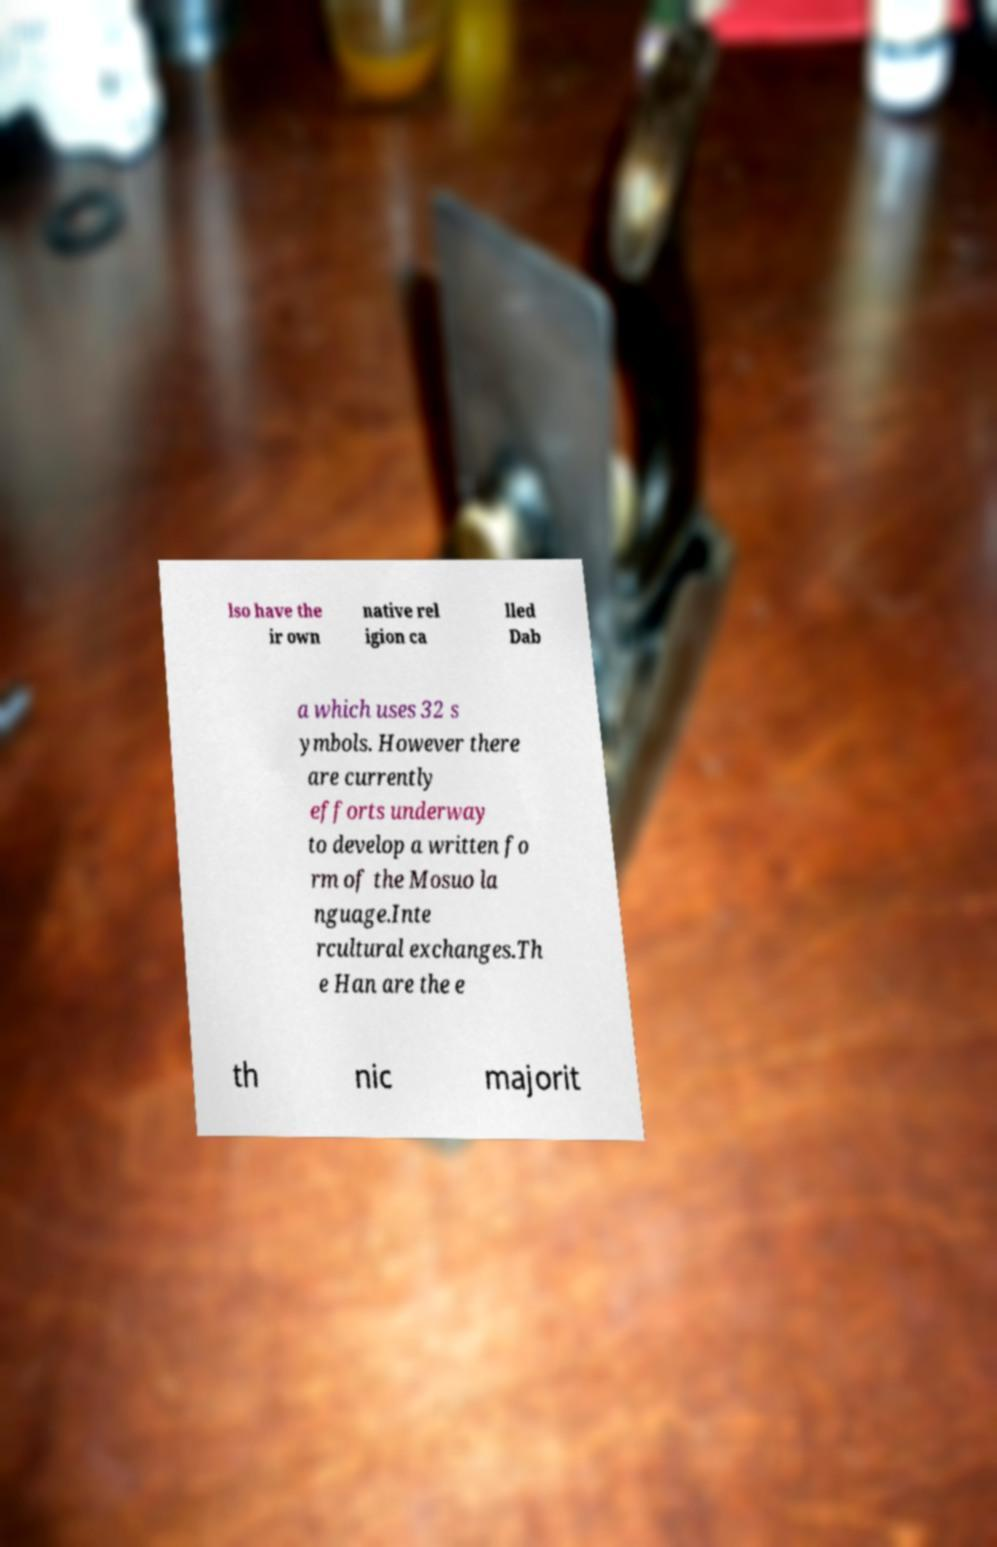Can you read and provide the text displayed in the image?This photo seems to have some interesting text. Can you extract and type it out for me? lso have the ir own native rel igion ca lled Dab a which uses 32 s ymbols. However there are currently efforts underway to develop a written fo rm of the Mosuo la nguage.Inte rcultural exchanges.Th e Han are the e th nic majorit 